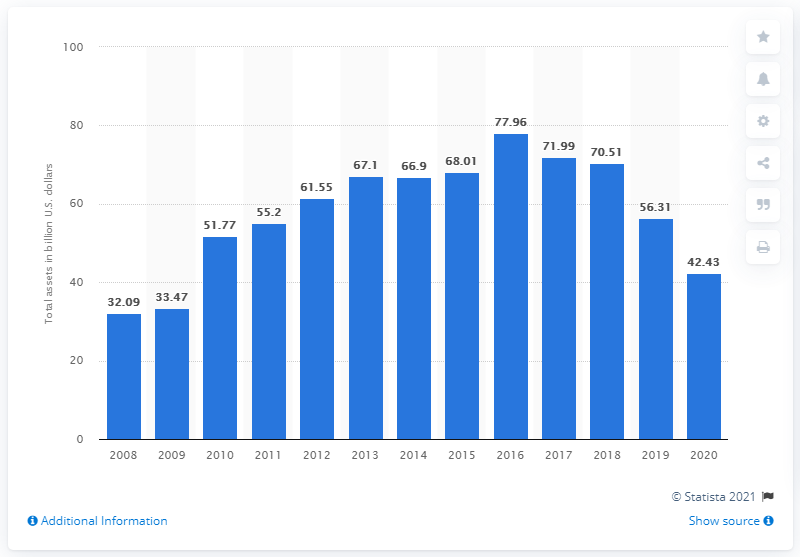Mention a couple of crucial points in this snapshot. In 2020, the total assets of Schlumberger were worth approximately 42.43 billion dollars. 